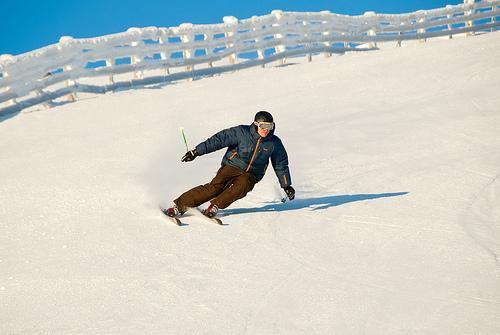How many people are in the picture?
Give a very brief answer. 1. 